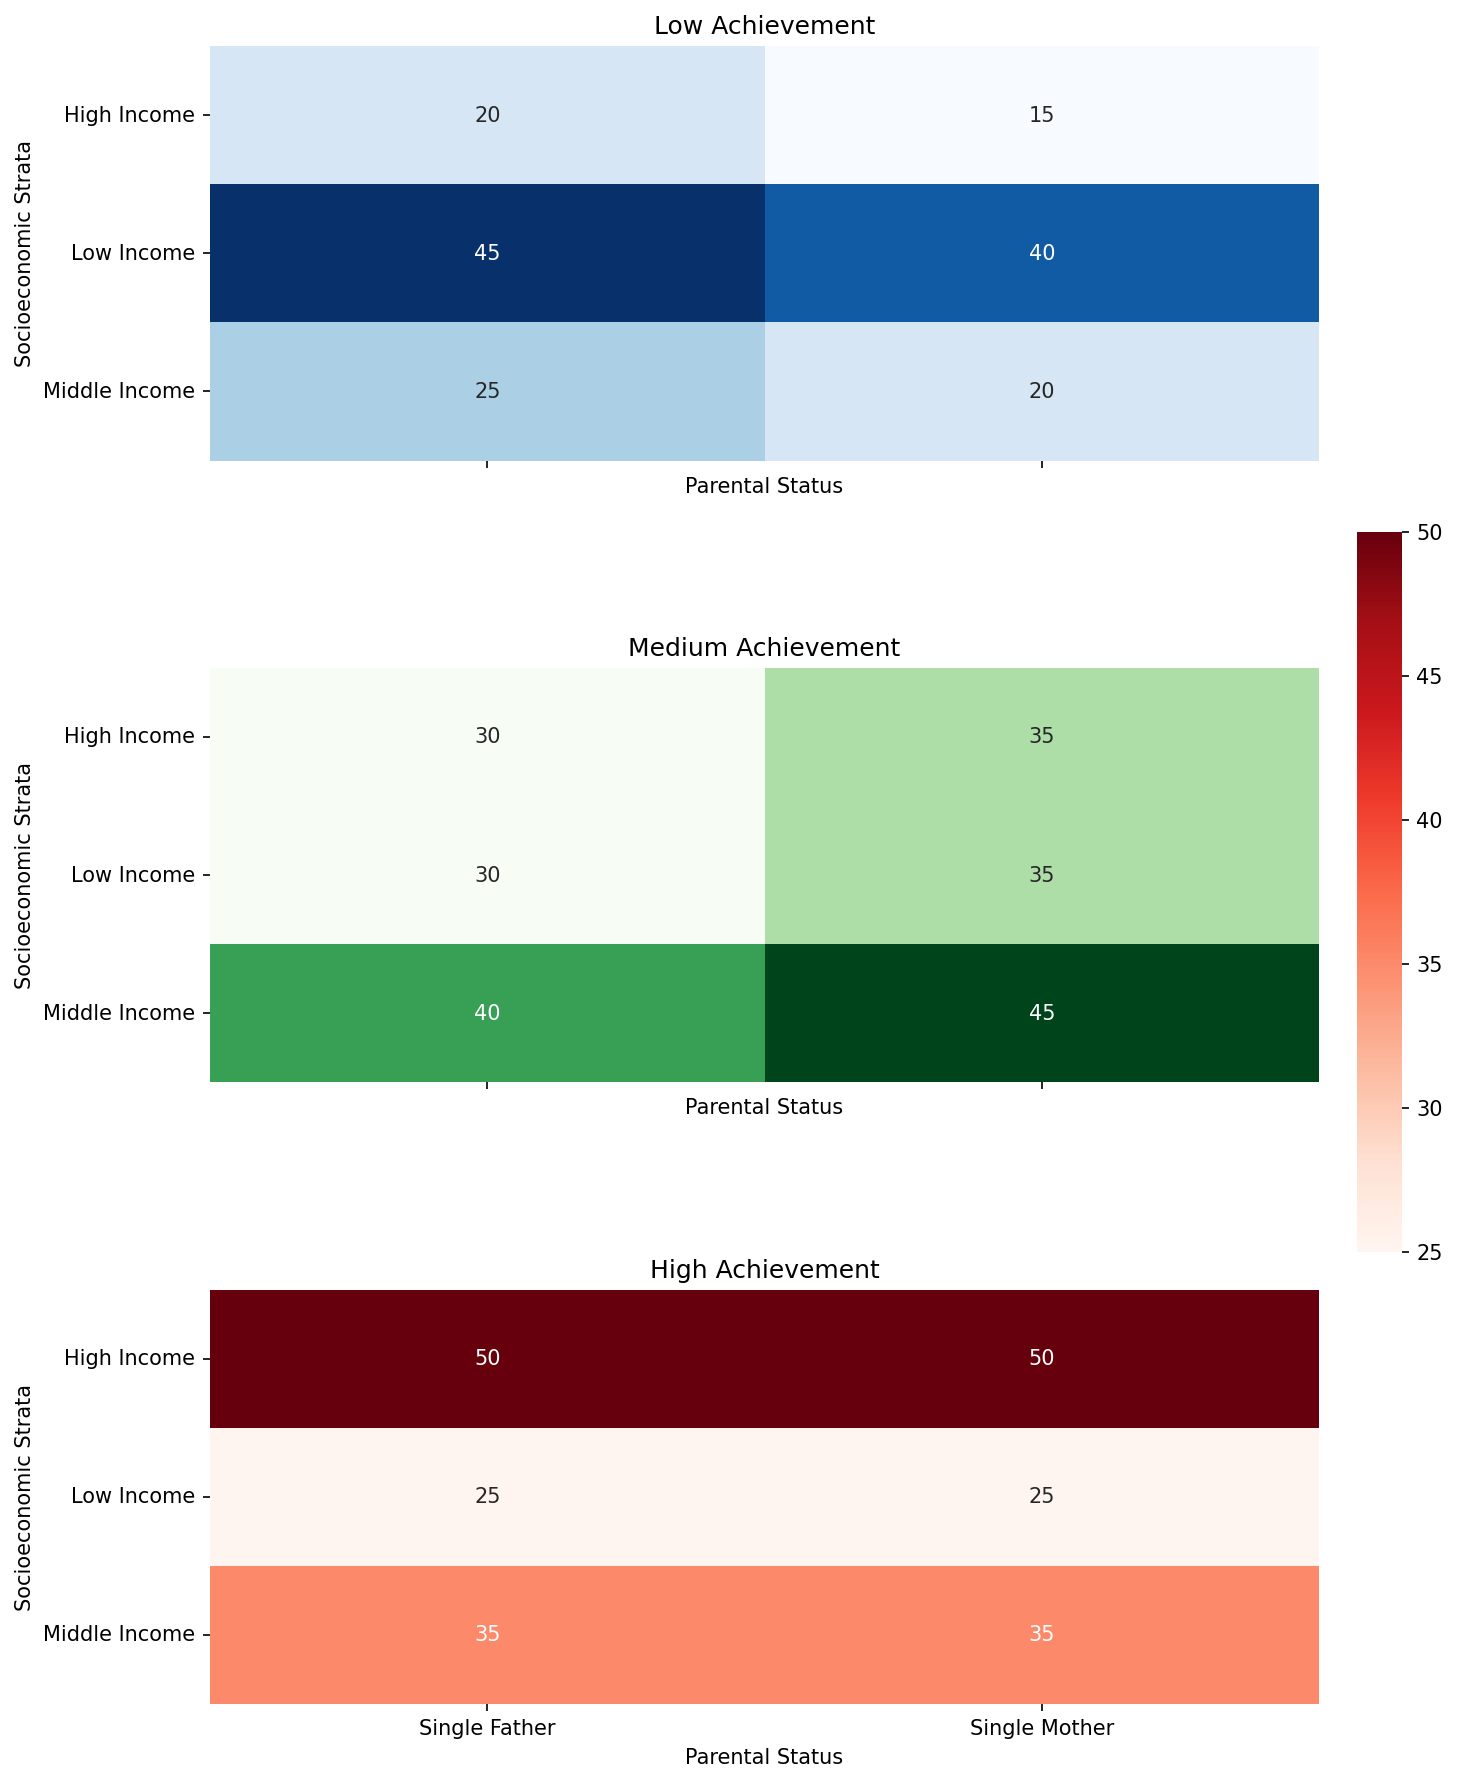What is the difference in low achievement rates between children from low-income single-mother and single-father households? The low achievement rate for children from low-income single-mother households is 40%, while for single-father households, it is 45%. Therefore, the difference is 45% - 40% = 5%.
Answer: 5% Which group has the highest rate of high achievement among all the categories? The highest rate of high achievement occurs in both high-income single-mother and single-father households, each with a rate of 50%.
Answer: High-income households (both single mother and single father) What is the average medium achievement rate for middle-income households? The medium achievement rates for middle-income single-mother and single-father households are 45% and 40%, respectively. The average is (45 + 40) / 2 = 42.5%.
Answer: 42.5% How does the medium achievement rate of children from high-income single-mother households compare to that of single-father households? For high-income households, the medium achievement rate is 35% for single-mother households and 30% for single-father households. Hence, single-mother households have a 5% higher medium achievement rate.
Answer: Single-mother households have a 5% higher rate Which subgroup in low-income households has the highest educational achievement rate? In low-income households, both single-mother and single-father households have the same high achievement rate of 25%.
Answer: Both single-mother and single-father households What is the sum of high achievement rates for middle-income single-mother and high-income single-father households? The high achievement rate for middle-income single-mother households is 35%, and for high-income single-father households, it is 50%. Therefore, the sum is 35% + 50% = 85%.
Answer: 85% How much greater is the low achievement rate in low-income households compared to high-income households for both parental statuses? The rate of low achievement in low-income single-mother households is 40%, and in single-father households, it is 45%. For high-income households, the rates are 15% for single mothers and 20% for single fathers. The differences are 40% - 15% = 25% for single mothers and 45% - 20% = 25% for single fathers.
Answer: 25% greater for both What is the combined medium achievement rate across all socioeconomic strata for children of single mothers? The medium achievement rates for single mothers are 35% (low income), 45% (middle income), and 35% (high income). The combined value is 35 + 45 + 35 = 115%.
Answer: 115% Is the rate of low achievement for children of single mothers in middle-income households lower than that for children of single fathers in the same income bracket? For middle-income households, the low achievement rate is 20% for children of single mothers and 25% for children of single fathers. Hence, it is indeed lower.
Answer: Yes What is the difference between the highest and lowest achievement rates in medium-income single-parent households? In medium-income single-parent households, the highest achievement rate is 45% (single mothers, medium achievement), and the lowest is 20% (single mothers, low achievement). The difference is 45% - 20% = 25%.
Answer: 25% 